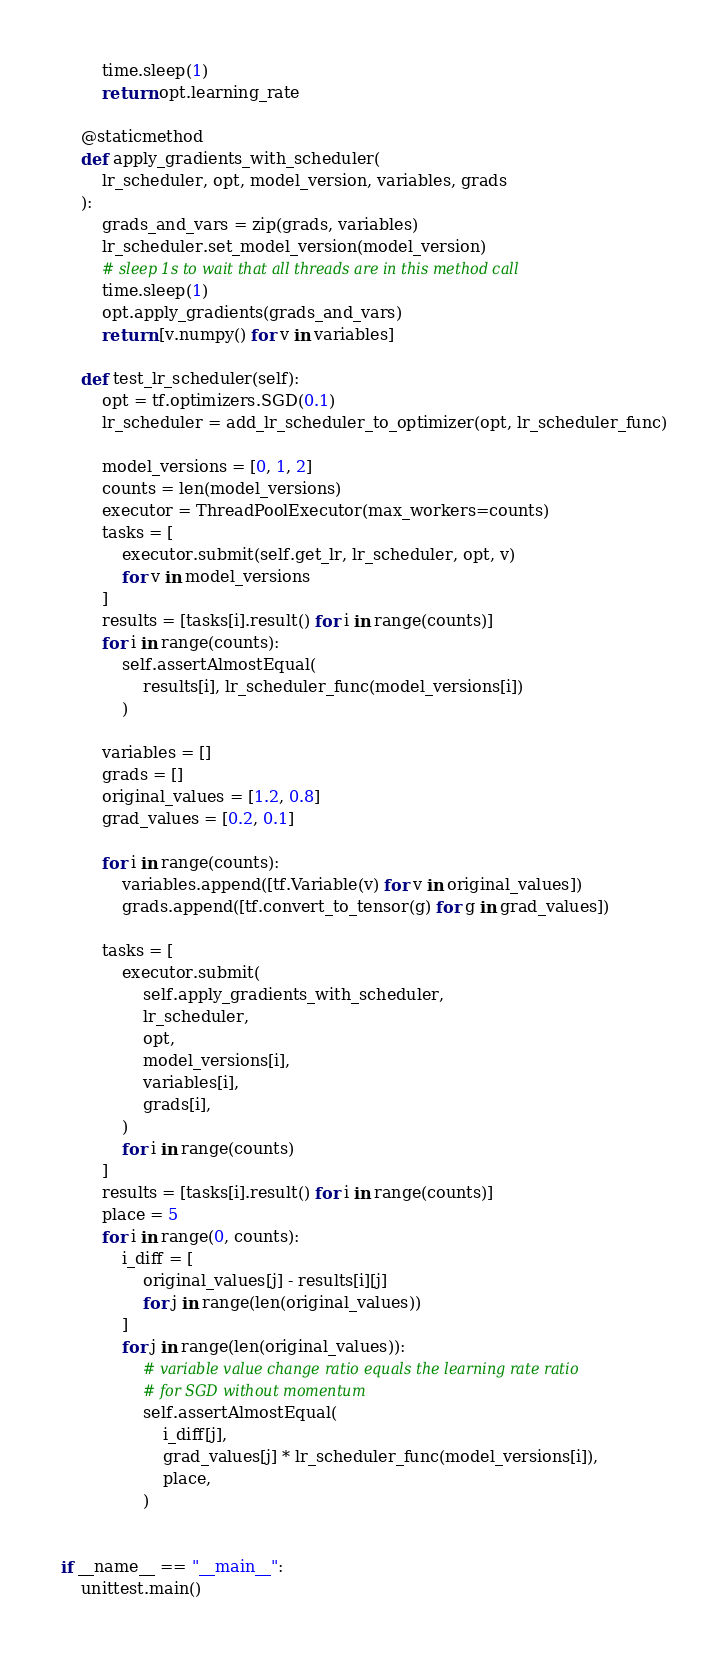<code> <loc_0><loc_0><loc_500><loc_500><_Python_>        time.sleep(1)
        return opt.learning_rate

    @staticmethod
    def apply_gradients_with_scheduler(
        lr_scheduler, opt, model_version, variables, grads
    ):
        grads_and_vars = zip(grads, variables)
        lr_scheduler.set_model_version(model_version)
        # sleep 1s to wait that all threads are in this method call
        time.sleep(1)
        opt.apply_gradients(grads_and_vars)
        return [v.numpy() for v in variables]

    def test_lr_scheduler(self):
        opt = tf.optimizers.SGD(0.1)
        lr_scheduler = add_lr_scheduler_to_optimizer(opt, lr_scheduler_func)

        model_versions = [0, 1, 2]
        counts = len(model_versions)
        executor = ThreadPoolExecutor(max_workers=counts)
        tasks = [
            executor.submit(self.get_lr, lr_scheduler, opt, v)
            for v in model_versions
        ]
        results = [tasks[i].result() for i in range(counts)]
        for i in range(counts):
            self.assertAlmostEqual(
                results[i], lr_scheduler_func(model_versions[i])
            )

        variables = []
        grads = []
        original_values = [1.2, 0.8]
        grad_values = [0.2, 0.1]

        for i in range(counts):
            variables.append([tf.Variable(v) for v in original_values])
            grads.append([tf.convert_to_tensor(g) for g in grad_values])

        tasks = [
            executor.submit(
                self.apply_gradients_with_scheduler,
                lr_scheduler,
                opt,
                model_versions[i],
                variables[i],
                grads[i],
            )
            for i in range(counts)
        ]
        results = [tasks[i].result() for i in range(counts)]
        place = 5
        for i in range(0, counts):
            i_diff = [
                original_values[j] - results[i][j]
                for j in range(len(original_values))
            ]
            for j in range(len(original_values)):
                # variable value change ratio equals the learning rate ratio
                # for SGD without momentum
                self.assertAlmostEqual(
                    i_diff[j],
                    grad_values[j] * lr_scheduler_func(model_versions[i]),
                    place,
                )


if __name__ == "__main__":
    unittest.main()
</code> 